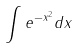<formula> <loc_0><loc_0><loc_500><loc_500>\int e ^ { - x ^ { 2 } } d x</formula> 